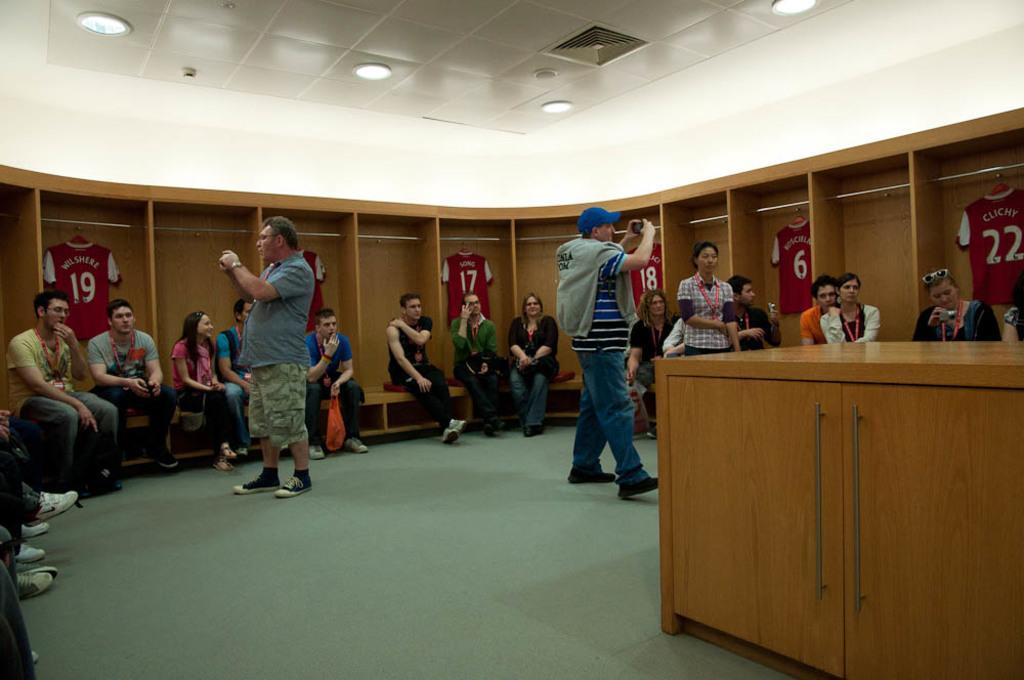Describe this image in one or two sentences. In the image there are people sitting around the room on a bench in front of cupboards with jerseys inside it and two men standing in the middle taking pictures and above there are lights over the ceiling. 